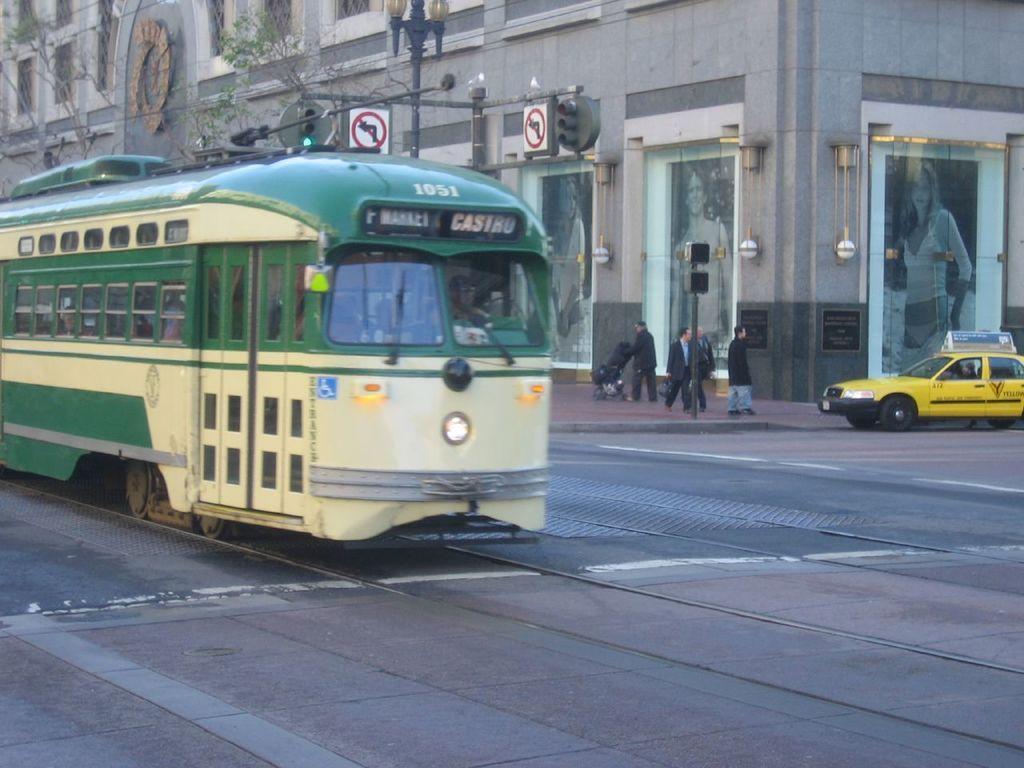Please provide a concise description of this image. In this image we can see a few people, one of them is pushing a stroller, there are traffic lights, light poles, sign boards, there is a train, a car on the road, there is a building, there are posters of people on the walls, also we can see trees. 